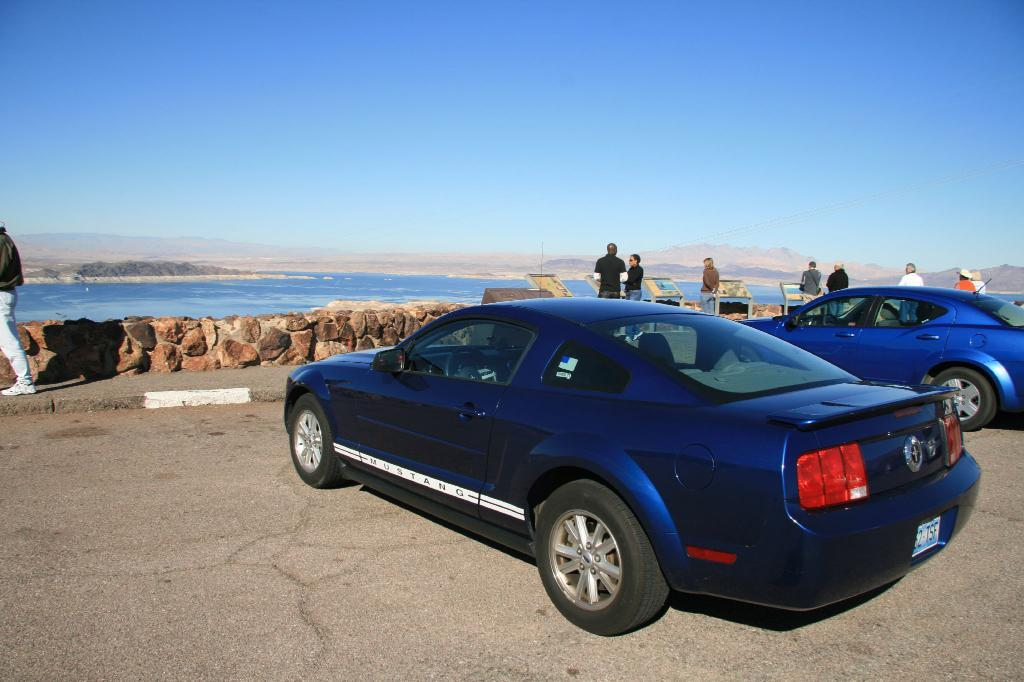How many cars are present in the image? There are two cars in the image. What else can be seen in the image besides the cars? There are people on a path and water visible in the image. What type of natural feature is present in the image? There are mountains in the image. What type of sweater is the person wearing in the image? There is no person wearing a sweater in the image. How many cakes are visible in the image? There are no cakes present in the image. 